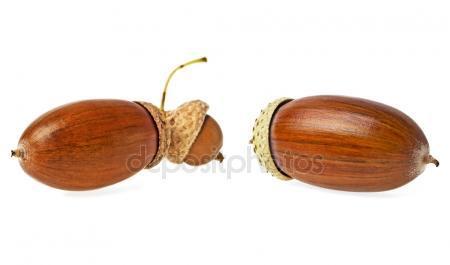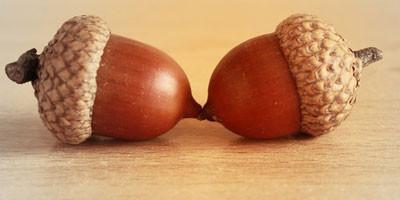The first image is the image on the left, the second image is the image on the right. Considering the images on both sides, is "Each image contains exactly two acorns with their caps on, and at least one of the images features acorns with caps back-to-back and joined at the stem top." valid? Answer yes or no. No. The first image is the image on the left, the second image is the image on the right. Evaluate the accuracy of this statement regarding the images: "The left and right image contains the same number of real acorns.". Is it true? Answer yes or no. No. 